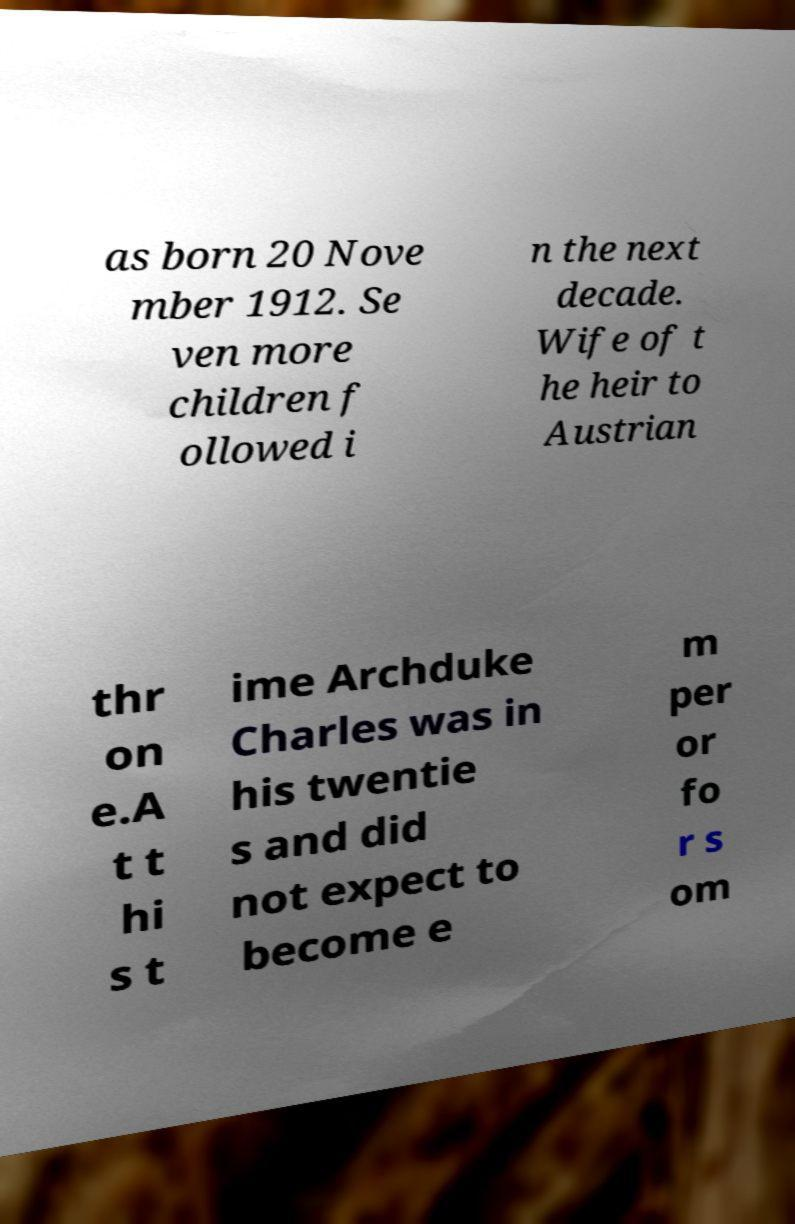Please identify and transcribe the text found in this image. as born 20 Nove mber 1912. Se ven more children f ollowed i n the next decade. Wife of t he heir to Austrian thr on e.A t t hi s t ime Archduke Charles was in his twentie s and did not expect to become e m per or fo r s om 